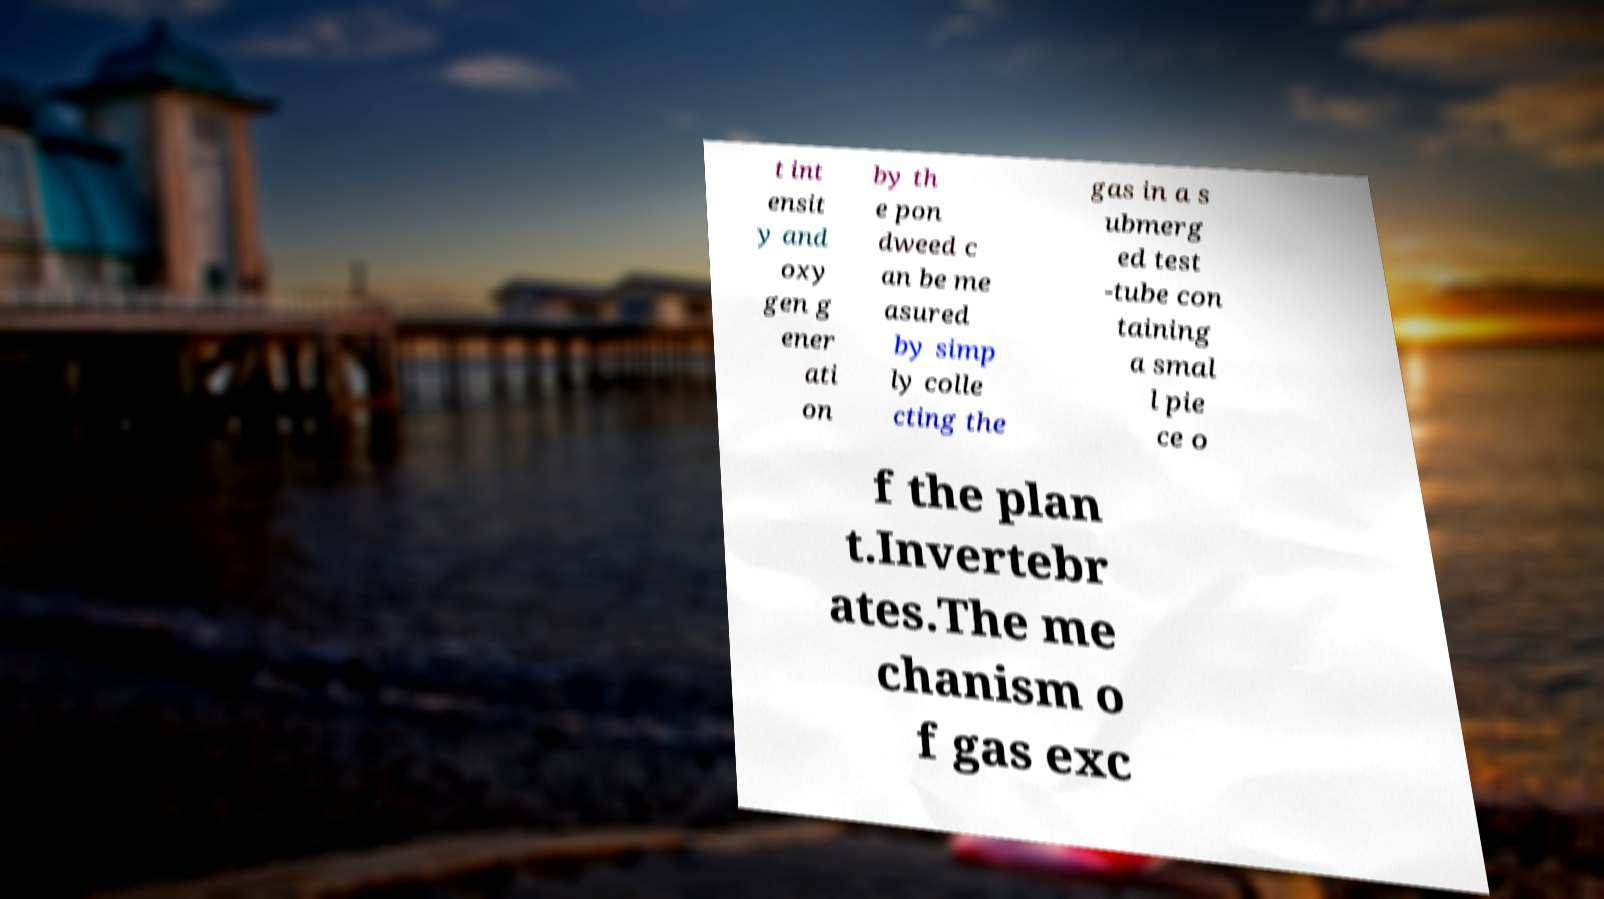What messages or text are displayed in this image? I need them in a readable, typed format. t int ensit y and oxy gen g ener ati on by th e pon dweed c an be me asured by simp ly colle cting the gas in a s ubmerg ed test -tube con taining a smal l pie ce o f the plan t.Invertebr ates.The me chanism o f gas exc 